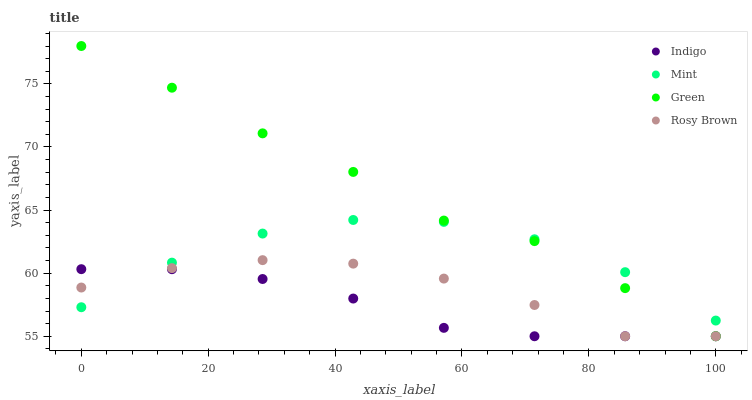Does Indigo have the minimum area under the curve?
Answer yes or no. Yes. Does Green have the maximum area under the curve?
Answer yes or no. Yes. Does Rosy Brown have the minimum area under the curve?
Answer yes or no. No. Does Rosy Brown have the maximum area under the curve?
Answer yes or no. No. Is Indigo the smoothest?
Answer yes or no. Yes. Is Mint the roughest?
Answer yes or no. Yes. Is Rosy Brown the smoothest?
Answer yes or no. No. Is Rosy Brown the roughest?
Answer yes or no. No. Does Rosy Brown have the lowest value?
Answer yes or no. Yes. Does Green have the highest value?
Answer yes or no. Yes. Does Rosy Brown have the highest value?
Answer yes or no. No. Does Rosy Brown intersect Green?
Answer yes or no. Yes. Is Rosy Brown less than Green?
Answer yes or no. No. Is Rosy Brown greater than Green?
Answer yes or no. No. 